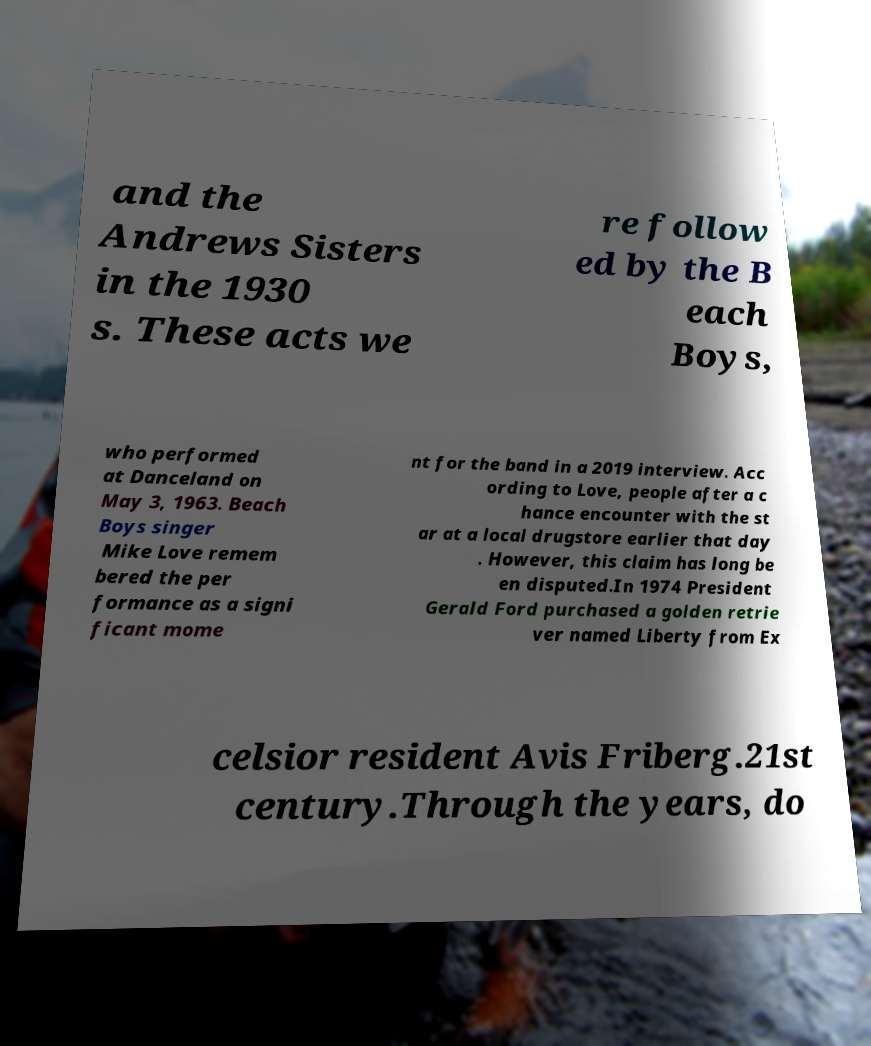Can you accurately transcribe the text from the provided image for me? and the Andrews Sisters in the 1930 s. These acts we re follow ed by the B each Boys, who performed at Danceland on May 3, 1963. Beach Boys singer Mike Love remem bered the per formance as a signi ficant mome nt for the band in a 2019 interview. Acc ording to Love, people after a c hance encounter with the st ar at a local drugstore earlier that day . However, this claim has long be en disputed.In 1974 President Gerald Ford purchased a golden retrie ver named Liberty from Ex celsior resident Avis Friberg.21st century.Through the years, do 